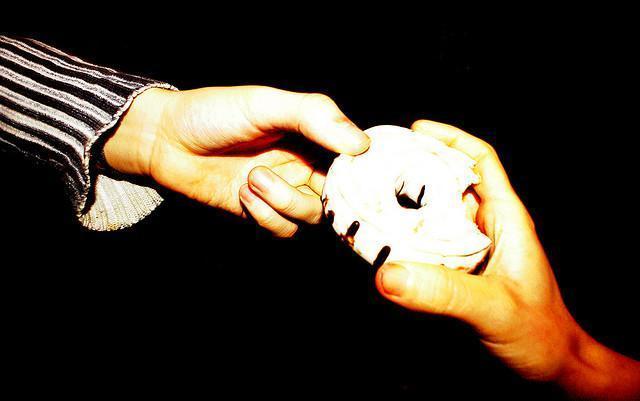How many people can you see?
Give a very brief answer. 2. How many brown cows are there on the beach?
Give a very brief answer. 0. 